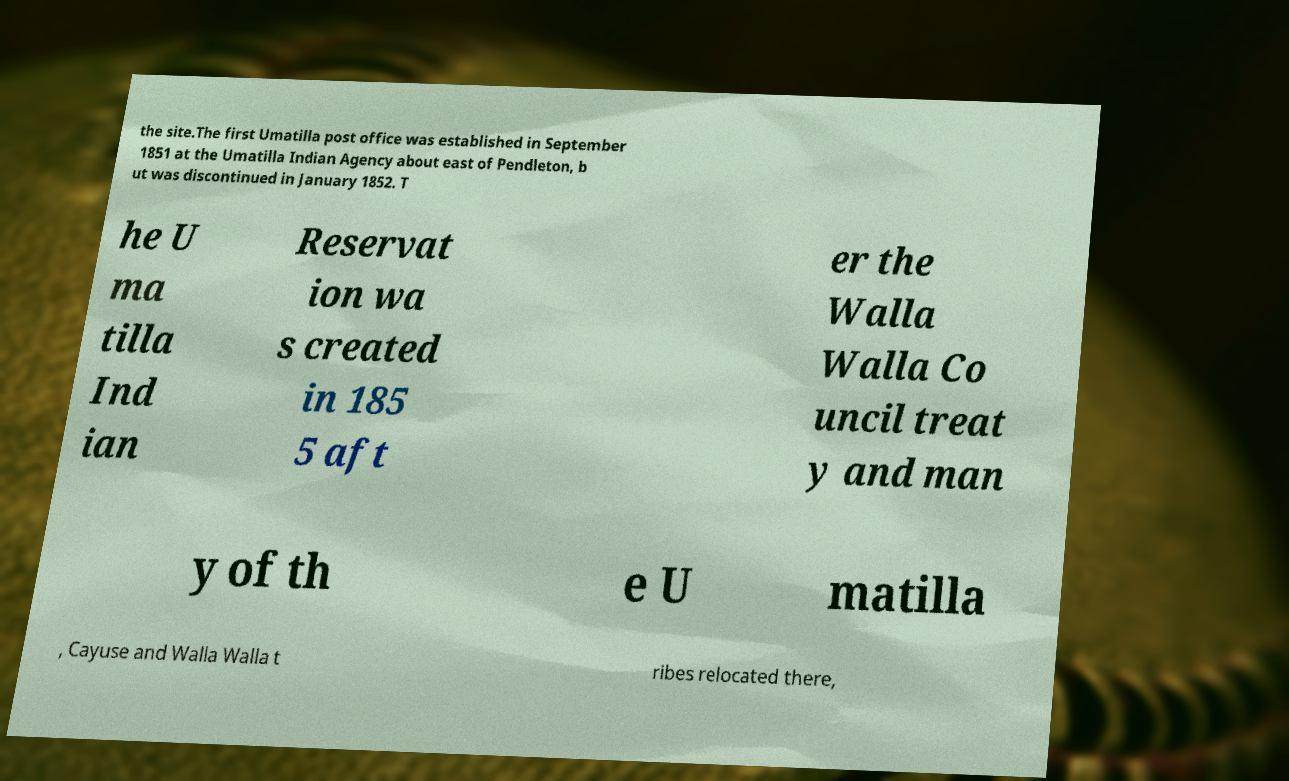For documentation purposes, I need the text within this image transcribed. Could you provide that? the site.The first Umatilla post office was established in September 1851 at the Umatilla Indian Agency about east of Pendleton, b ut was discontinued in January 1852. T he U ma tilla Ind ian Reservat ion wa s created in 185 5 aft er the Walla Walla Co uncil treat y and man y of th e U matilla , Cayuse and Walla Walla t ribes relocated there, 